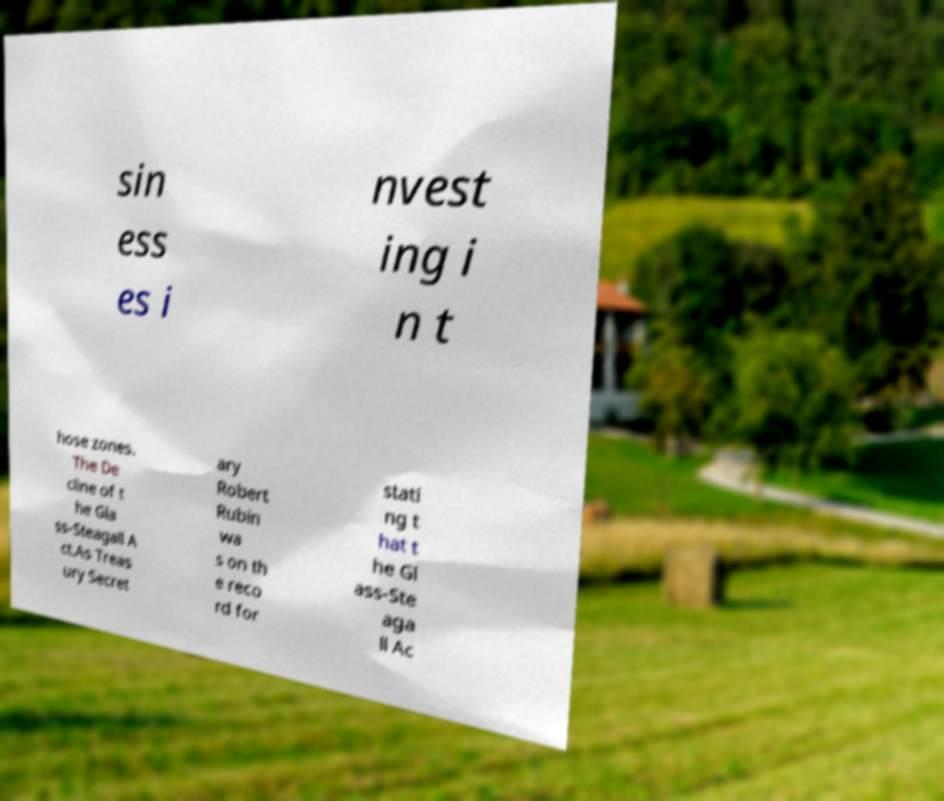I need the written content from this picture converted into text. Can you do that? sin ess es i nvest ing i n t hose zones. The De cline of t he Gla ss-Steagall A ct.As Treas ury Secret ary Robert Rubin wa s on th e reco rd for stati ng t hat t he Gl ass-Ste aga ll Ac 